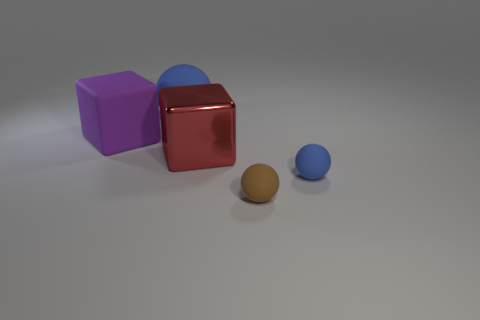Add 5 red shiny blocks. How many objects exist? 10 Subtract all blue balls. How many balls are left? 1 Subtract all brown cylinders. How many blue balls are left? 2 Subtract 1 cubes. How many cubes are left? 1 Subtract all cubes. How many objects are left? 3 Subtract all blue balls. How many balls are left? 1 Subtract 1 brown spheres. How many objects are left? 4 Subtract all gray balls. Subtract all gray cylinders. How many balls are left? 3 Subtract all brown balls. Subtract all blue cylinders. How many objects are left? 4 Add 2 red cubes. How many red cubes are left? 3 